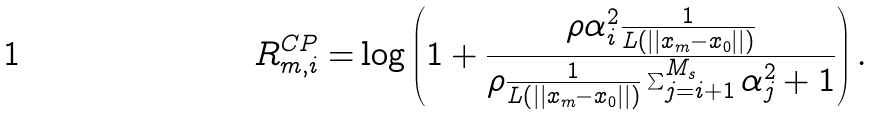Convert formula to latex. <formula><loc_0><loc_0><loc_500><loc_500>R ^ { C P } _ { m , i } = & \log \left ( 1 + \frac { \rho \alpha _ { i } ^ { 2 } \frac { 1 } { L \left ( | | x _ { m } - x _ { 0 } | | \right ) } } { \rho \frac { 1 } { L \left ( | | x _ { m } - x _ { 0 } | | \right ) } \sum ^ { M _ { s } } _ { j = i + 1 } \alpha _ { j } ^ { 2 } + 1 } \right ) .</formula> 